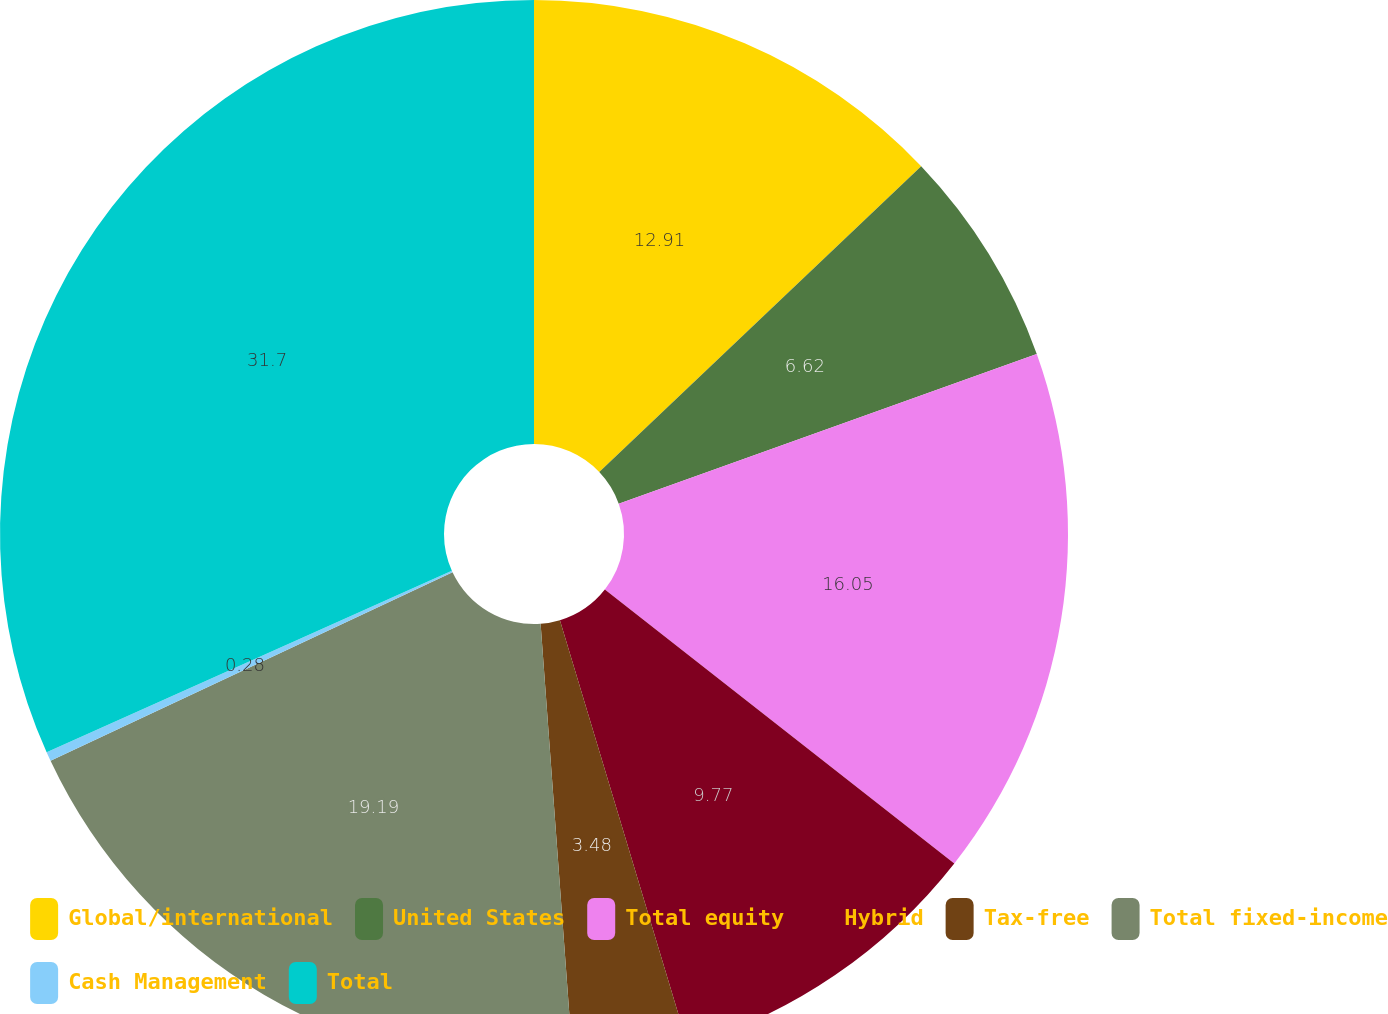Convert chart. <chart><loc_0><loc_0><loc_500><loc_500><pie_chart><fcel>Global/international<fcel>United States<fcel>Total equity<fcel>Hybrid<fcel>Tax-free<fcel>Total fixed-income<fcel>Cash Management<fcel>Total<nl><fcel>12.91%<fcel>6.62%<fcel>16.05%<fcel>9.77%<fcel>3.48%<fcel>19.19%<fcel>0.28%<fcel>31.7%<nl></chart> 